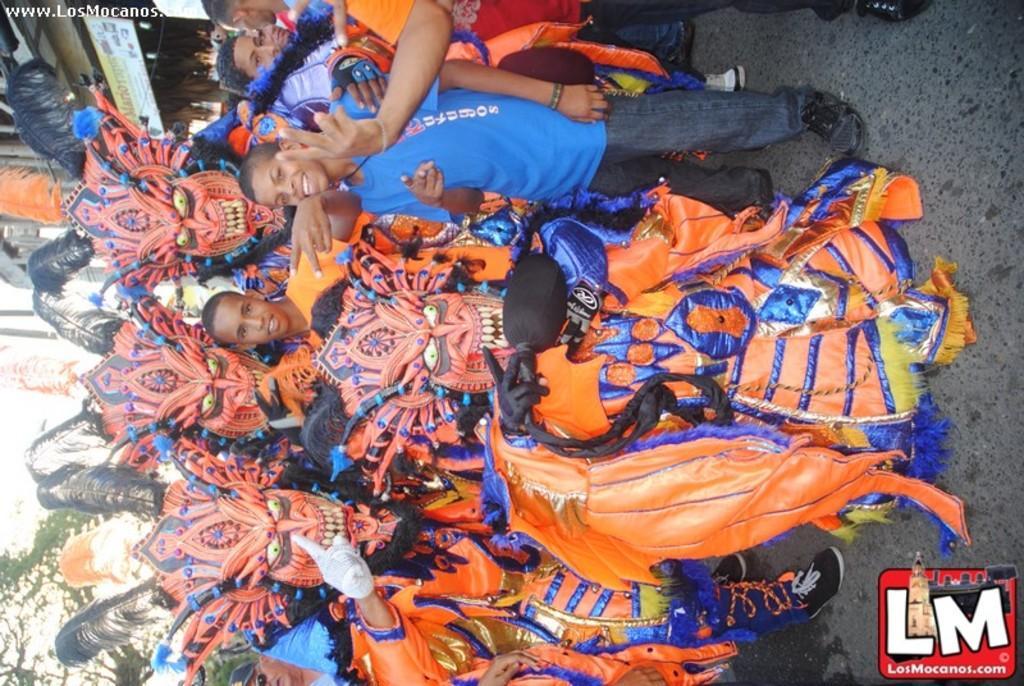How would you summarize this image in a sentence or two? In this image we can see few persons are standing on the road and among them few persons wore fancy dresses. In the background we can see trees, buildings and a hoarding board. On the right side at the bottom corner we can see a logo and texts written on the image. 